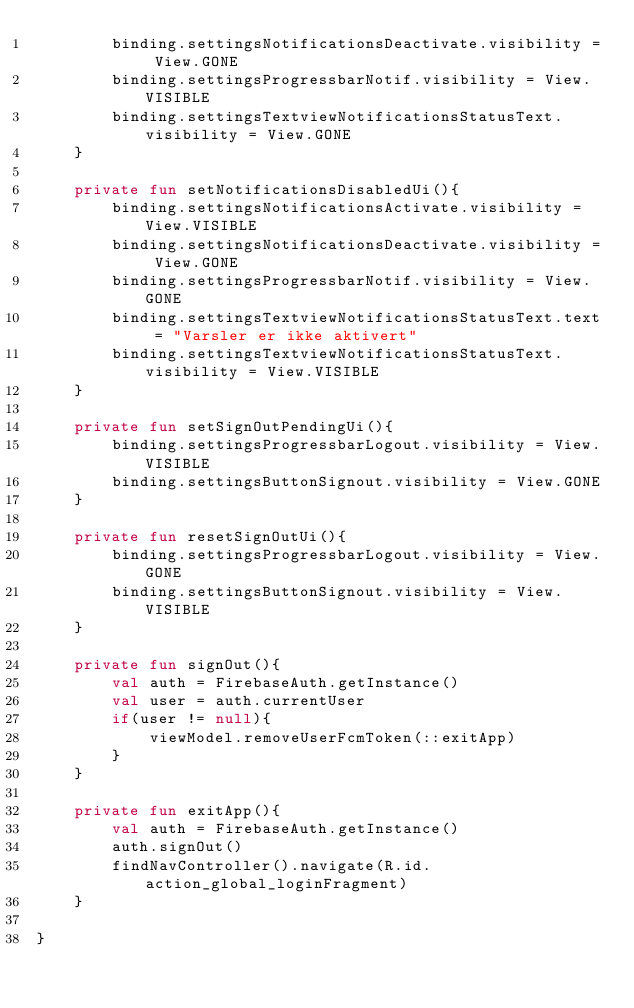<code> <loc_0><loc_0><loc_500><loc_500><_Kotlin_>        binding.settingsNotificationsDeactivate.visibility = View.GONE
        binding.settingsProgressbarNotif.visibility = View.VISIBLE
        binding.settingsTextviewNotificationsStatusText.visibility = View.GONE
    }

    private fun setNotificationsDisabledUi(){
        binding.settingsNotificationsActivate.visibility = View.VISIBLE
        binding.settingsNotificationsDeactivate.visibility = View.GONE
        binding.settingsProgressbarNotif.visibility = View.GONE
        binding.settingsTextviewNotificationsStatusText.text = "Varsler er ikke aktivert"
        binding.settingsTextviewNotificationsStatusText.visibility = View.VISIBLE
    }

    private fun setSignOutPendingUi(){
        binding.settingsProgressbarLogout.visibility = View.VISIBLE
        binding.settingsButtonSignout.visibility = View.GONE
    }

    private fun resetSignOutUi(){
        binding.settingsProgressbarLogout.visibility = View.GONE
        binding.settingsButtonSignout.visibility = View.VISIBLE
    }

    private fun signOut(){
        val auth = FirebaseAuth.getInstance()
        val user = auth.currentUser
        if(user != null){
            viewModel.removeUserFcmToken(::exitApp)
        }
    }

    private fun exitApp(){
        val auth = FirebaseAuth.getInstance()
        auth.signOut()
        findNavController().navigate(R.id.action_global_loginFragment)
    }

}</code> 